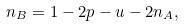<formula> <loc_0><loc_0><loc_500><loc_500>n _ { B } = 1 - 2 p - u - 2 n _ { A } ,</formula> 